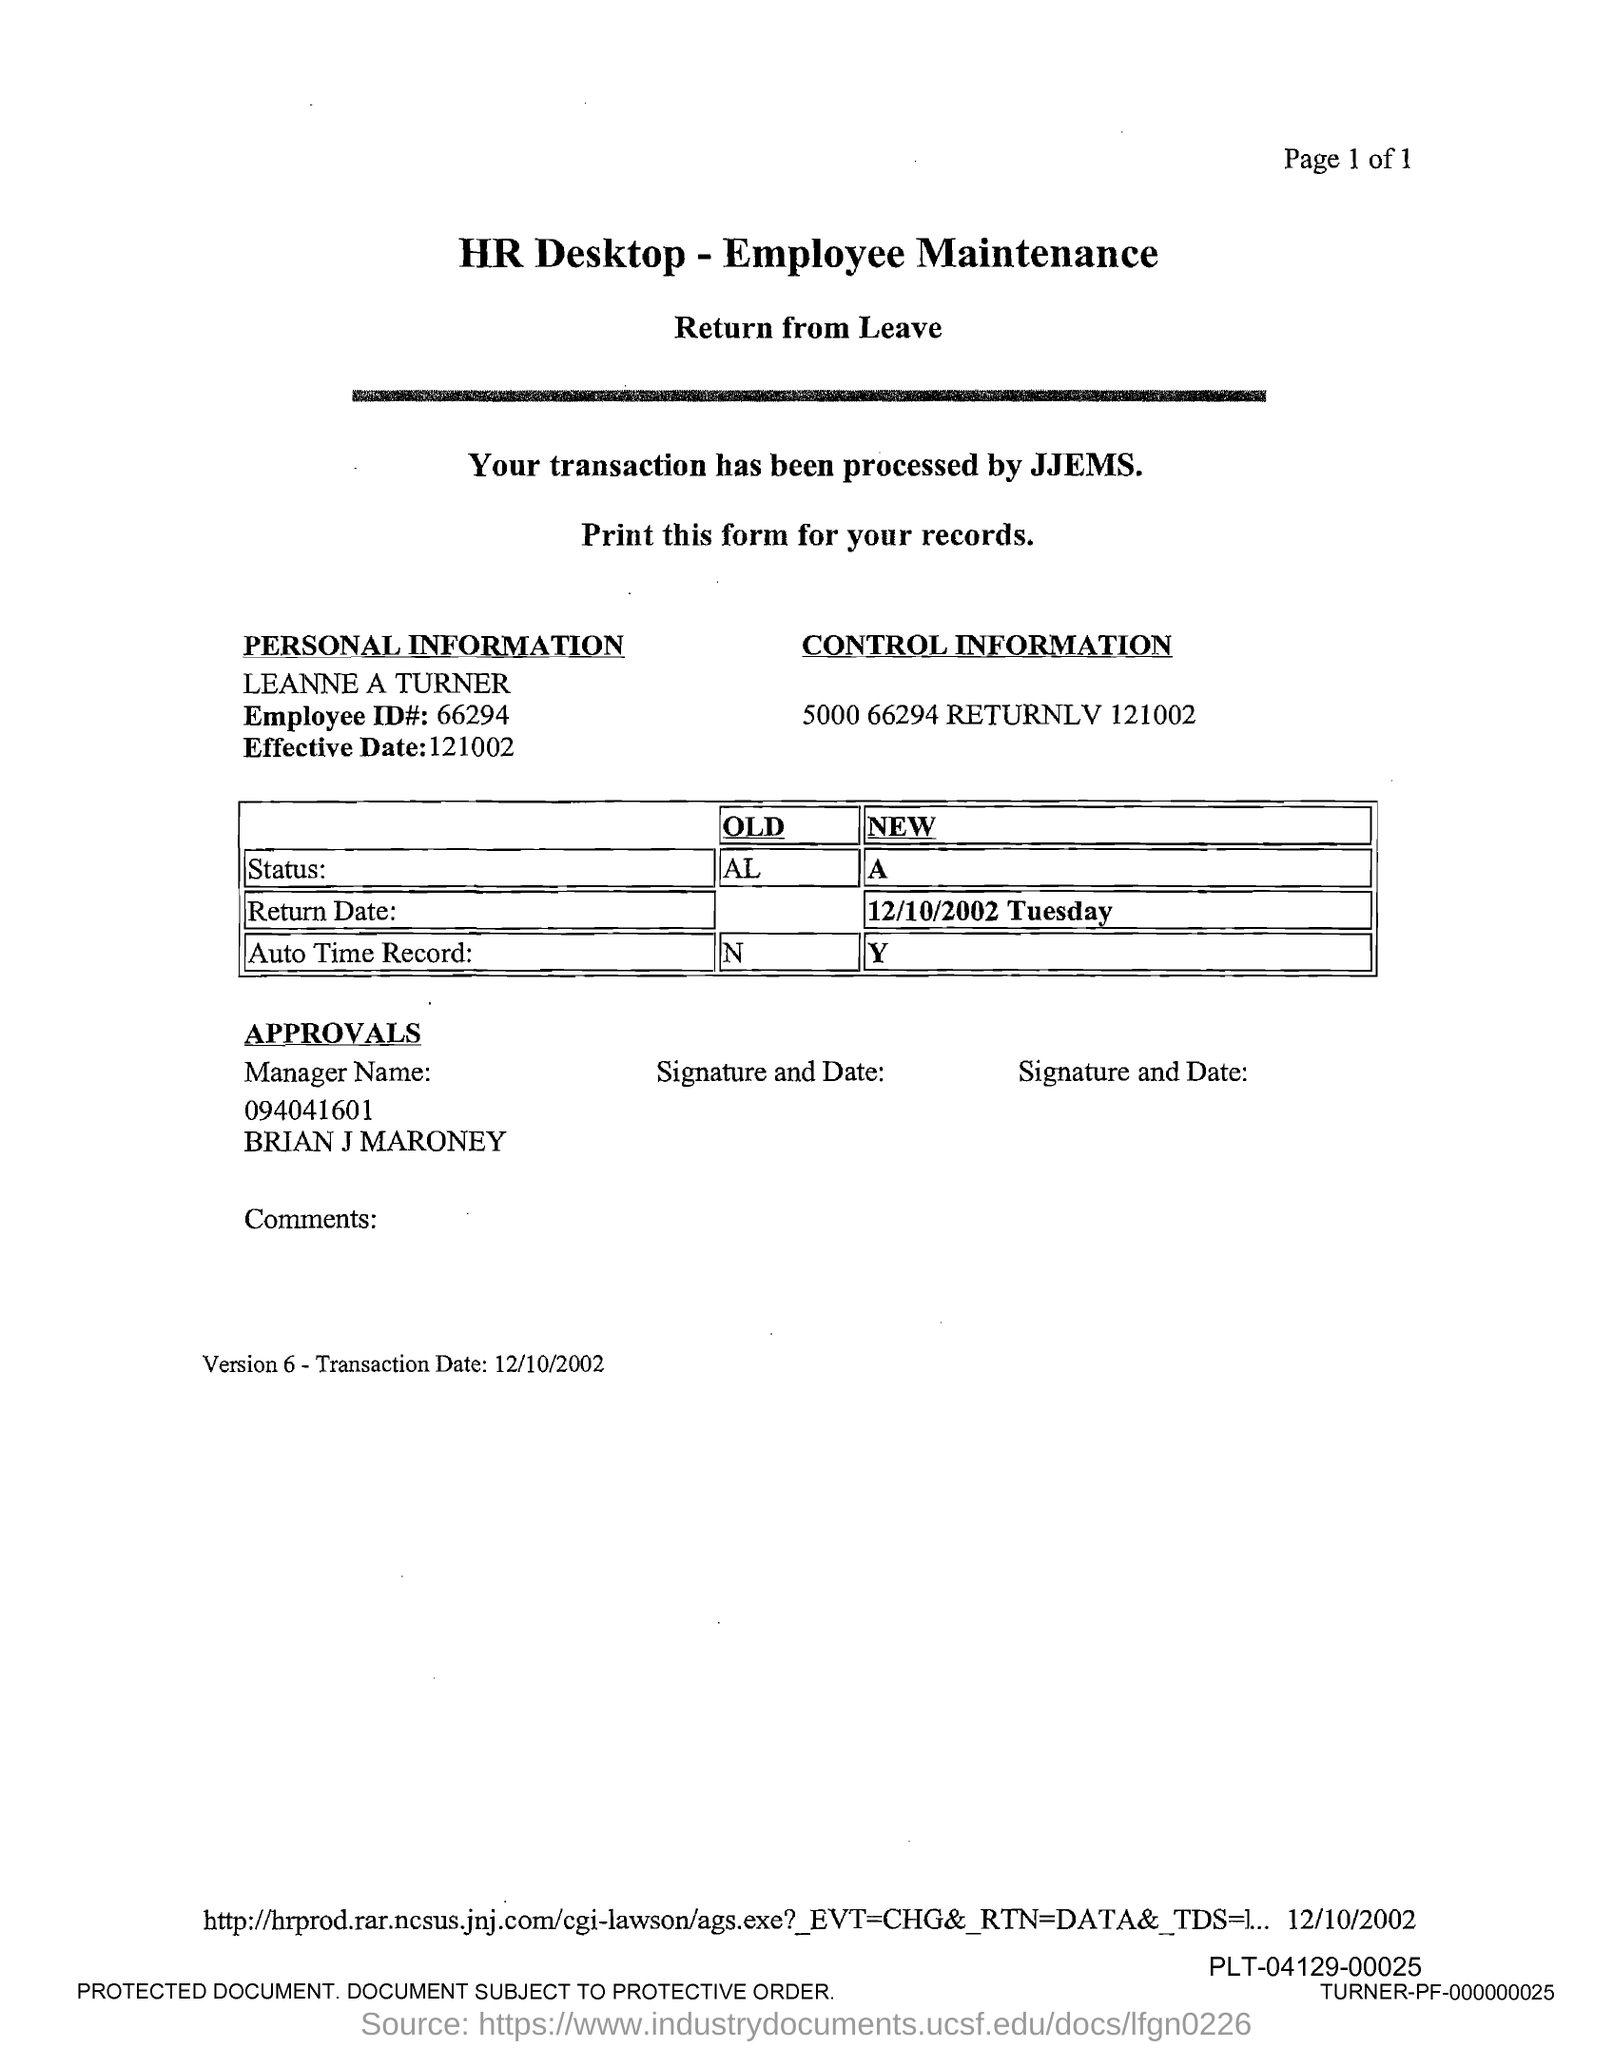What is the employee id# ?
Give a very brief answer. 66294. What is the effective date?
Offer a terse response. 121002. 